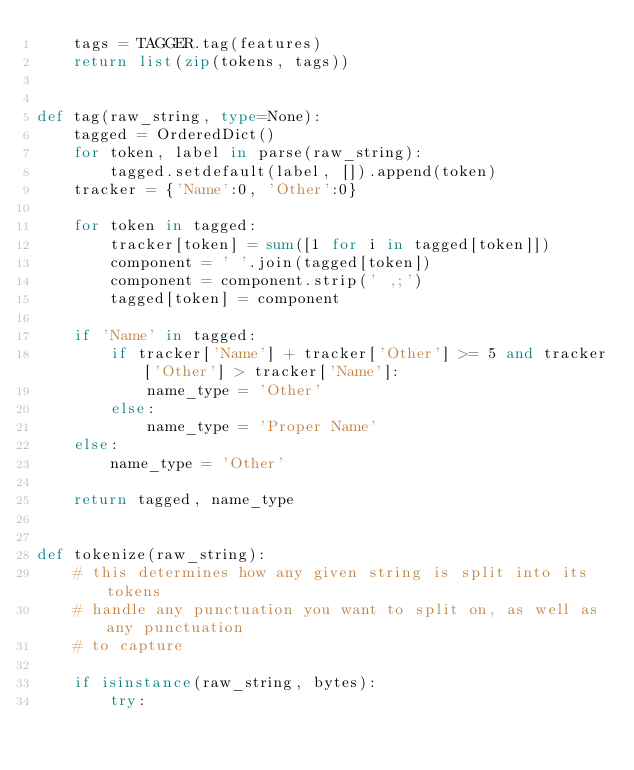<code> <loc_0><loc_0><loc_500><loc_500><_Python_>    tags = TAGGER.tag(features)
    return list(zip(tokens, tags))


def tag(raw_string, type=None):
    tagged = OrderedDict()
    for token, label in parse(raw_string):
        tagged.setdefault(label, []).append(token)
    tracker = {'Name':0, 'Other':0}

    for token in tagged:
        tracker[token] = sum([1 for i in tagged[token]])
        component = ' '.join(tagged[token])
        component = component.strip(' ,;')
        tagged[token] = component

    if 'Name' in tagged:
        if tracker['Name'] + tracker['Other'] >= 5 and tracker['Other'] > tracker['Name']:
            name_type = 'Other'
        else:
            name_type = 'Proper Name'
    else:
        name_type = 'Other'

    return tagged, name_type


def tokenize(raw_string):
    # this determines how any given string is split into its tokens
    # handle any punctuation you want to split on, as well as any punctuation
    # to capture

    if isinstance(raw_string, bytes):
        try:</code> 